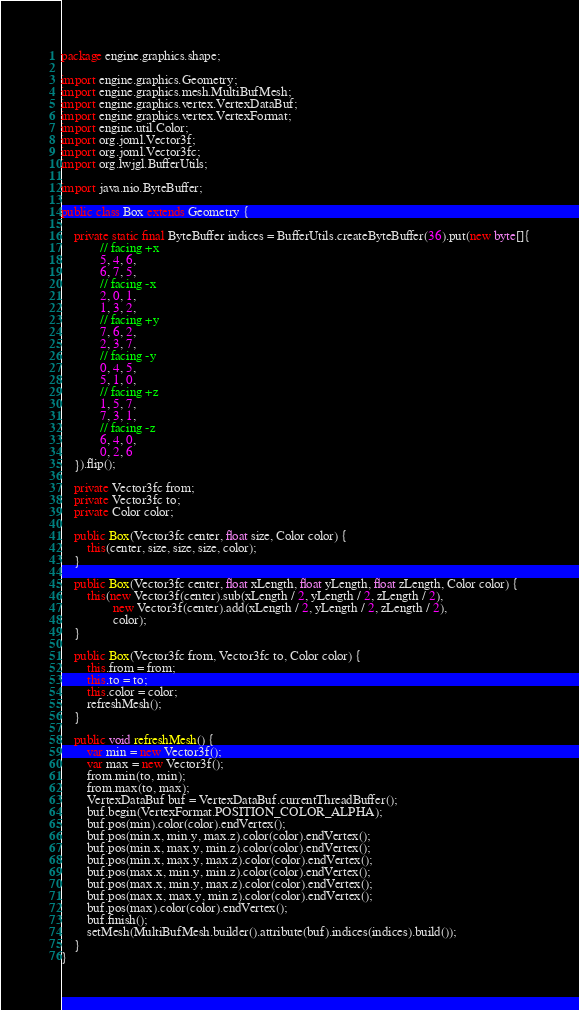<code> <loc_0><loc_0><loc_500><loc_500><_Java_>package engine.graphics.shape;

import engine.graphics.Geometry;
import engine.graphics.mesh.MultiBufMesh;
import engine.graphics.vertex.VertexDataBuf;
import engine.graphics.vertex.VertexFormat;
import engine.util.Color;
import org.joml.Vector3f;
import org.joml.Vector3fc;
import org.lwjgl.BufferUtils;

import java.nio.ByteBuffer;

public class Box extends Geometry {

    private static final ByteBuffer indices = BufferUtils.createByteBuffer(36).put(new byte[]{
            // facing +x
            5, 4, 6,
            6, 7, 5,
            // facing -x
            2, 0, 1,
            1, 3, 2,
            // facing +y
            7, 6, 2,
            2, 3, 7,
            // facing -y
            0, 4, 5,
            5, 1, 0,
            // facing +z
            1, 5, 7,
            7, 3, 1,
            // facing -z
            6, 4, 0,
            0, 2, 6
    }).flip();

    private Vector3fc from;
    private Vector3fc to;
    private Color color;

    public Box(Vector3fc center, float size, Color color) {
        this(center, size, size, size, color);
    }

    public Box(Vector3fc center, float xLength, float yLength, float zLength, Color color) {
        this(new Vector3f(center).sub(xLength / 2, yLength / 2, zLength / 2),
                new Vector3f(center).add(xLength / 2, yLength / 2, zLength / 2),
                color);
    }

    public Box(Vector3fc from, Vector3fc to, Color color) {
        this.from = from;
        this.to = to;
        this.color = color;
        refreshMesh();
    }

    public void refreshMesh() {
        var min = new Vector3f();
        var max = new Vector3f();
        from.min(to, min);
        from.max(to, max);
        VertexDataBuf buf = VertexDataBuf.currentThreadBuffer();
        buf.begin(VertexFormat.POSITION_COLOR_ALPHA);
        buf.pos(min).color(color).endVertex();
        buf.pos(min.x, min.y, max.z).color(color).endVertex();
        buf.pos(min.x, max.y, min.z).color(color).endVertex();
        buf.pos(min.x, max.y, max.z).color(color).endVertex();
        buf.pos(max.x, min.y, min.z).color(color).endVertex();
        buf.pos(max.x, min.y, max.z).color(color).endVertex();
        buf.pos(max.x, max.y, min.z).color(color).endVertex();
        buf.pos(max).color(color).endVertex();
        buf.finish();
        setMesh(MultiBufMesh.builder().attribute(buf).indices(indices).build());
    }
}
</code> 